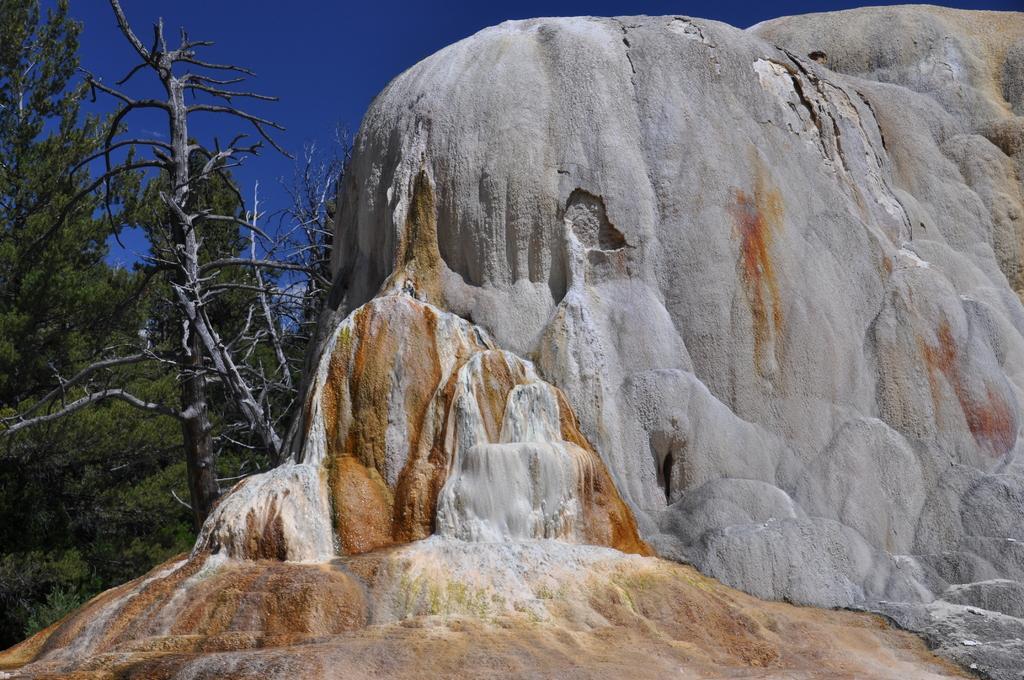Could you give a brief overview of what you see in this image? To the right side of the image there is a rock. To the left side of the image there are trees. At the top of the image there is sky. 